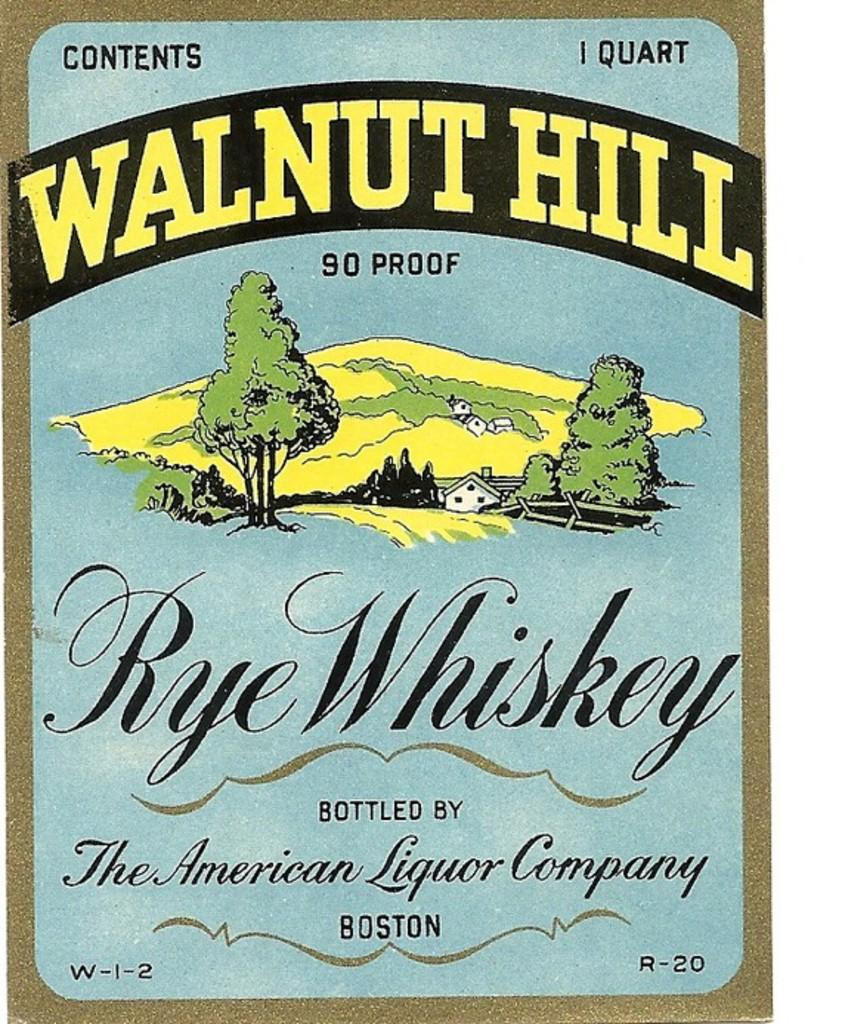What is the main object in the image? There is a poster in the image. What can be found on the poster? There is writing on the poster. What is depicted on the poster besides the writing? The poster depicts trees and a house. How many toes are visible on the poster? There are no toes depicted on the poster; it features writing, trees, and a house. 